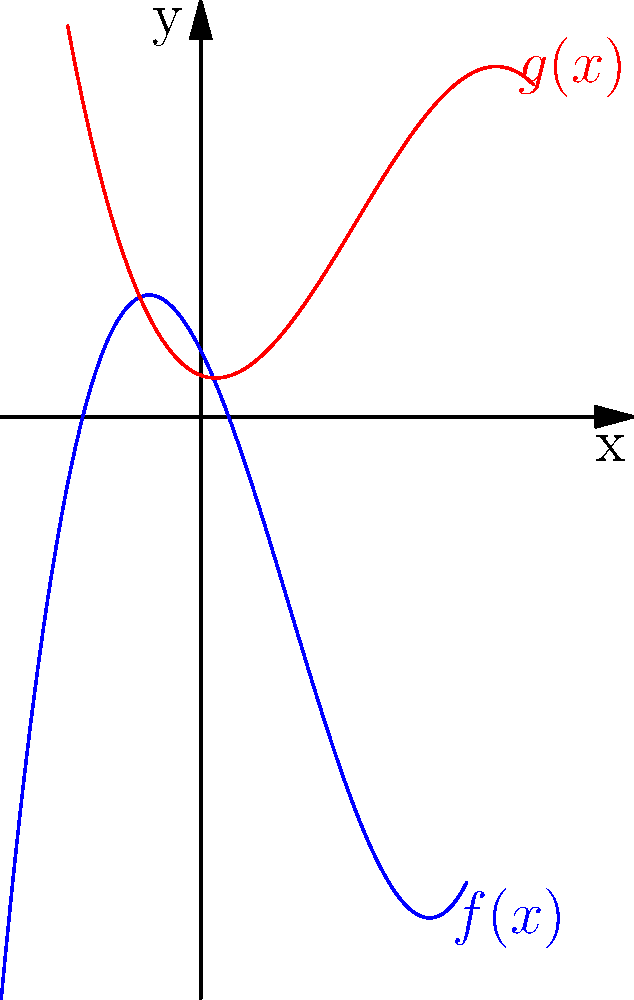As a YouTuber looking to grow your channel, you're analyzing your subscriber growth data. The blue curve represents your initial subscriber count function $f(x)$, and the red curve shows a transformed version $g(x)$. If $g(x) = -0.5(f(x-1) - 3)$, describe the transformations applied to $f(x)$ to obtain $g(x)$. How might understanding these transformations help you interpret changes in your subscriber growth patterns? Let's break down the transformations step-by-step:

1. Inside the parentheses, we have $(f(x-1) - 3)$:
   a. $f(x-1)$ represents a horizontal shift of 1 unit to the right.
   b. Subtracting 3 represents a vertical shift of 3 units down.

2. Outside the parentheses, we have $-0.5$ applied to the entire expression:
   a. The negative sign represents a reflection over the x-axis.
   b. The 0.5 represents a vertical compression by a factor of 2.

So, the complete sequence of transformations is:
1. Shift 1 unit right
2. Shift 3 units down
3. Reflect over the x-axis
4. Compress vertically by a factor of 2

Understanding these transformations can help interpret subscriber growth patterns:
- The horizontal shift might represent a delay in growth strategies taking effect.
- The vertical shift could indicate a baseline change in subscriber count.
- The reflection might show an inverse relationship between two growth metrics.
- The compression could represent a slower rate of change in subscriber growth.
Answer: Right shift 1, down 3, reflect over x-axis, compress vertically by factor of 2. 